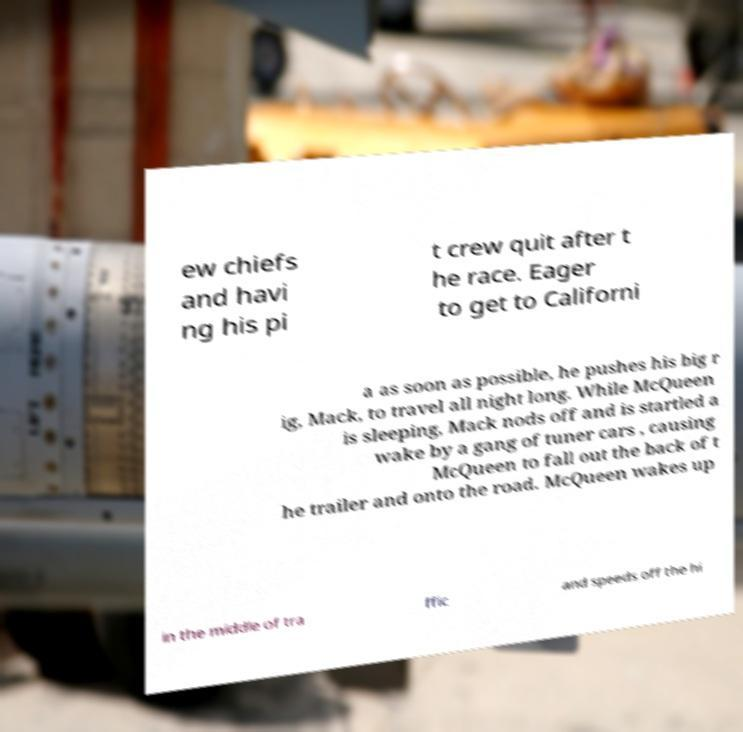Can you read and provide the text displayed in the image?This photo seems to have some interesting text. Can you extract and type it out for me? ew chiefs and havi ng his pi t crew quit after t he race. Eager to get to Californi a as soon as possible, he pushes his big r ig, Mack, to travel all night long. While McQueen is sleeping, Mack nods off and is startled a wake by a gang of tuner cars , causing McQueen to fall out the back of t he trailer and onto the road. McQueen wakes up in the middle of tra ffic and speeds off the hi 